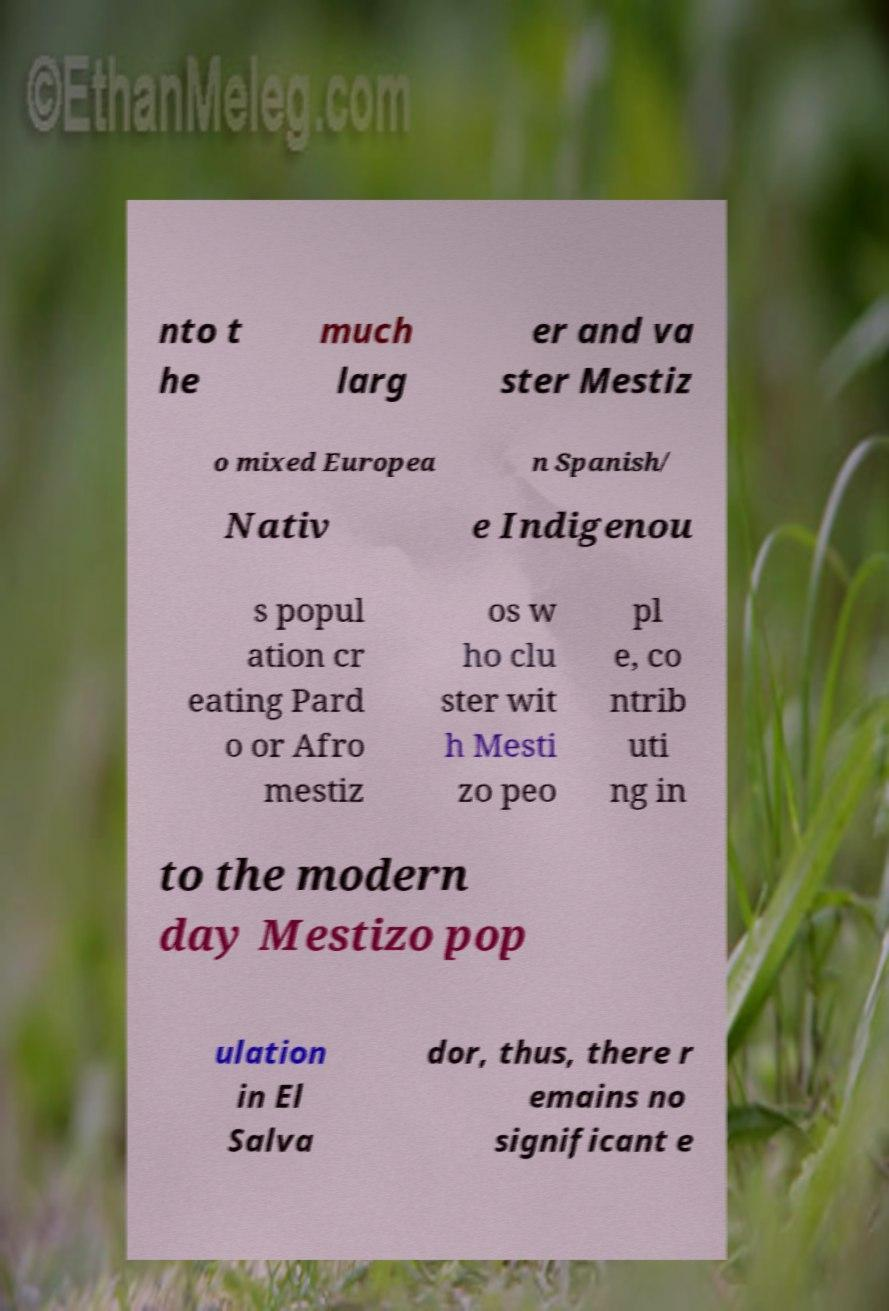For documentation purposes, I need the text within this image transcribed. Could you provide that? nto t he much larg er and va ster Mestiz o mixed Europea n Spanish/ Nativ e Indigenou s popul ation cr eating Pard o or Afro mestiz os w ho clu ster wit h Mesti zo peo pl e, co ntrib uti ng in to the modern day Mestizo pop ulation in El Salva dor, thus, there r emains no significant e 